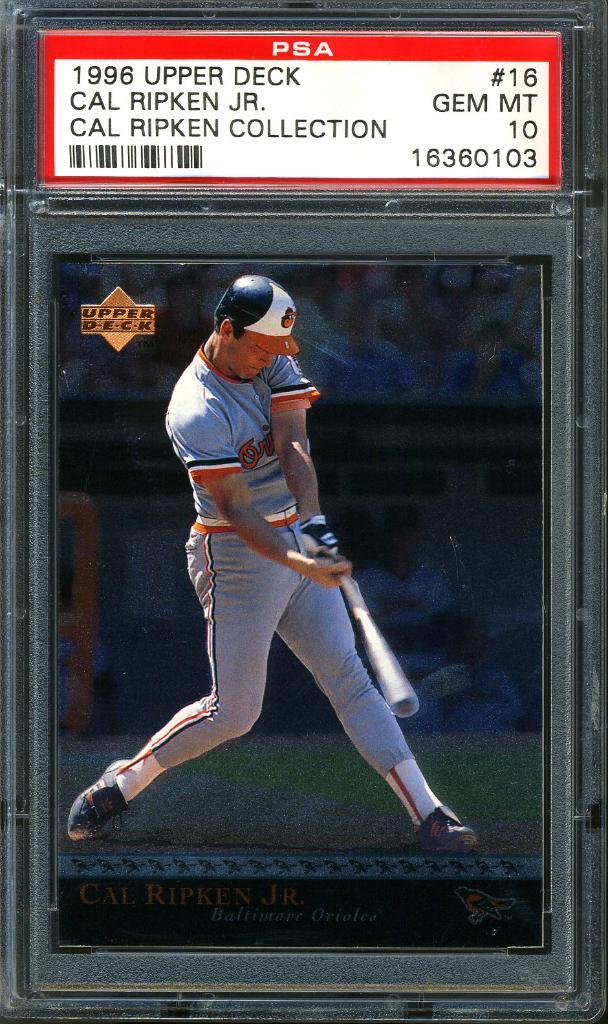<image>
Describe the image concisely. framed upper deck cal ripkin jr baseball card showing him in oriels uniform swinging the bat 